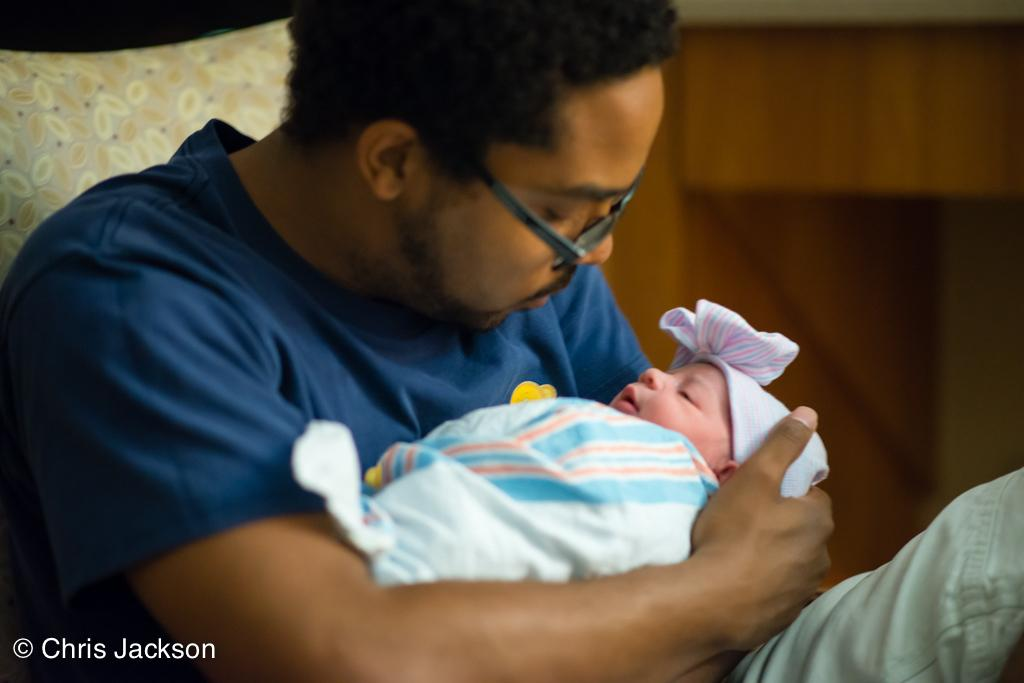What is the main subject of the image? There is a person in the image. What is the person in the image doing? The person is holding a baby. What can be seen on the baby's clothing? The baby is wearing a blue t-shirt. How many pigs are visible in the image? There are no pigs present in the image. What type of shock can be seen affecting the person in the image? There is no shock present in the image; the person is simply holding a baby. What type of cushion is being used by the person in the image? There is no cushion present in the image; the person is holding a baby. 